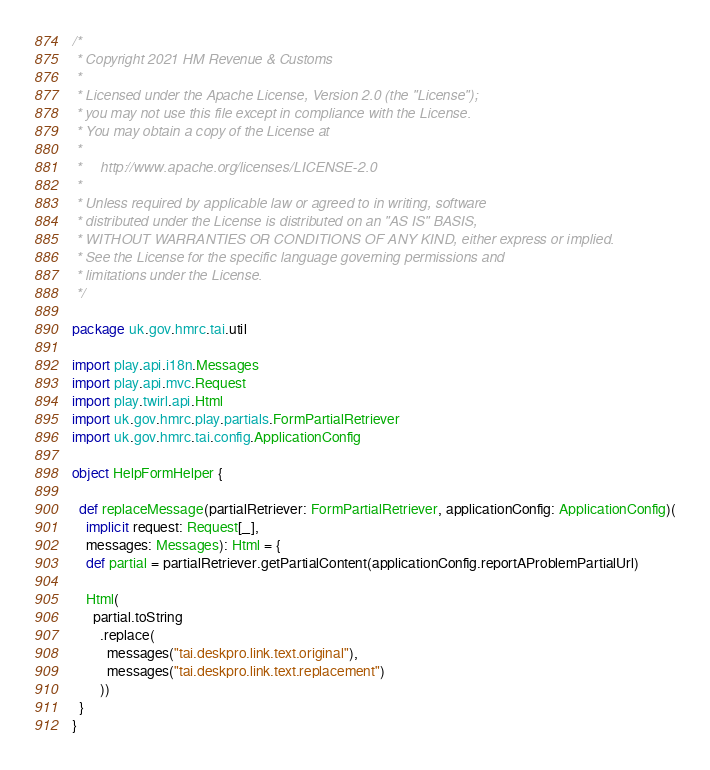Convert code to text. <code><loc_0><loc_0><loc_500><loc_500><_Scala_>/*
 * Copyright 2021 HM Revenue & Customs
 *
 * Licensed under the Apache License, Version 2.0 (the "License");
 * you may not use this file except in compliance with the License.
 * You may obtain a copy of the License at
 *
 *     http://www.apache.org/licenses/LICENSE-2.0
 *
 * Unless required by applicable law or agreed to in writing, software
 * distributed under the License is distributed on an "AS IS" BASIS,
 * WITHOUT WARRANTIES OR CONDITIONS OF ANY KIND, either express or implied.
 * See the License for the specific language governing permissions and
 * limitations under the License.
 */

package uk.gov.hmrc.tai.util

import play.api.i18n.Messages
import play.api.mvc.Request
import play.twirl.api.Html
import uk.gov.hmrc.play.partials.FormPartialRetriever
import uk.gov.hmrc.tai.config.ApplicationConfig

object HelpFormHelper {

  def replaceMessage(partialRetriever: FormPartialRetriever, applicationConfig: ApplicationConfig)(
    implicit request: Request[_],
    messages: Messages): Html = {
    def partial = partialRetriever.getPartialContent(applicationConfig.reportAProblemPartialUrl)

    Html(
      partial.toString
        .replace(
          messages("tai.deskpro.link.text.original"),
          messages("tai.deskpro.link.text.replacement")
        ))
  }
}
</code> 